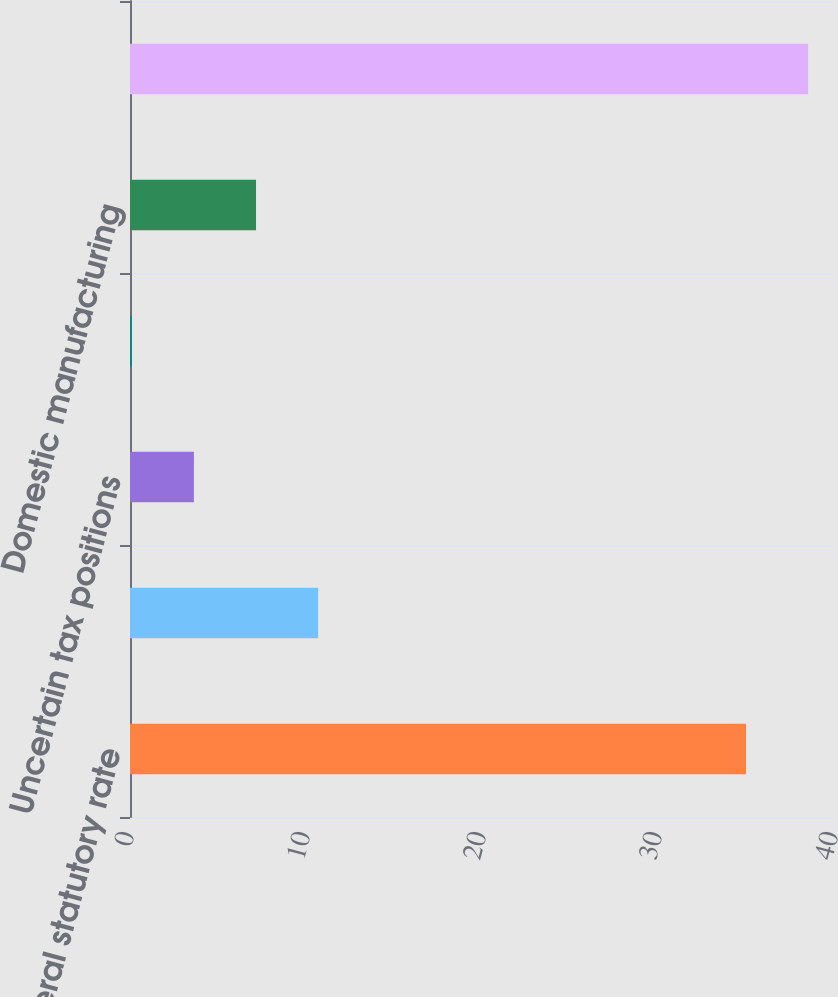Convert chart to OTSL. <chart><loc_0><loc_0><loc_500><loc_500><bar_chart><fcel>US federal statutory rate<fcel>State and local income taxes<fcel>Uncertain tax positions<fcel>SABMiller dividend benefit<fcel>Domestic manufacturing<fcel>Effective tax rate<nl><fcel>35<fcel>10.69<fcel>3.63<fcel>0.1<fcel>7.16<fcel>38.53<nl></chart> 